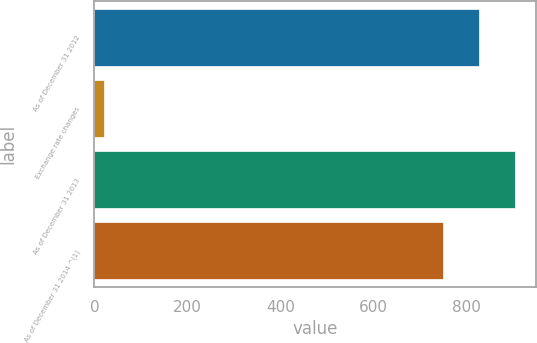<chart> <loc_0><loc_0><loc_500><loc_500><bar_chart><fcel>As of December 31 2012<fcel>Exchange rate changes<fcel>As of December 31 2013<fcel>As of December 31 2014 ^(1)<nl><fcel>826.7<fcel>21<fcel>904.4<fcel>749<nl></chart> 